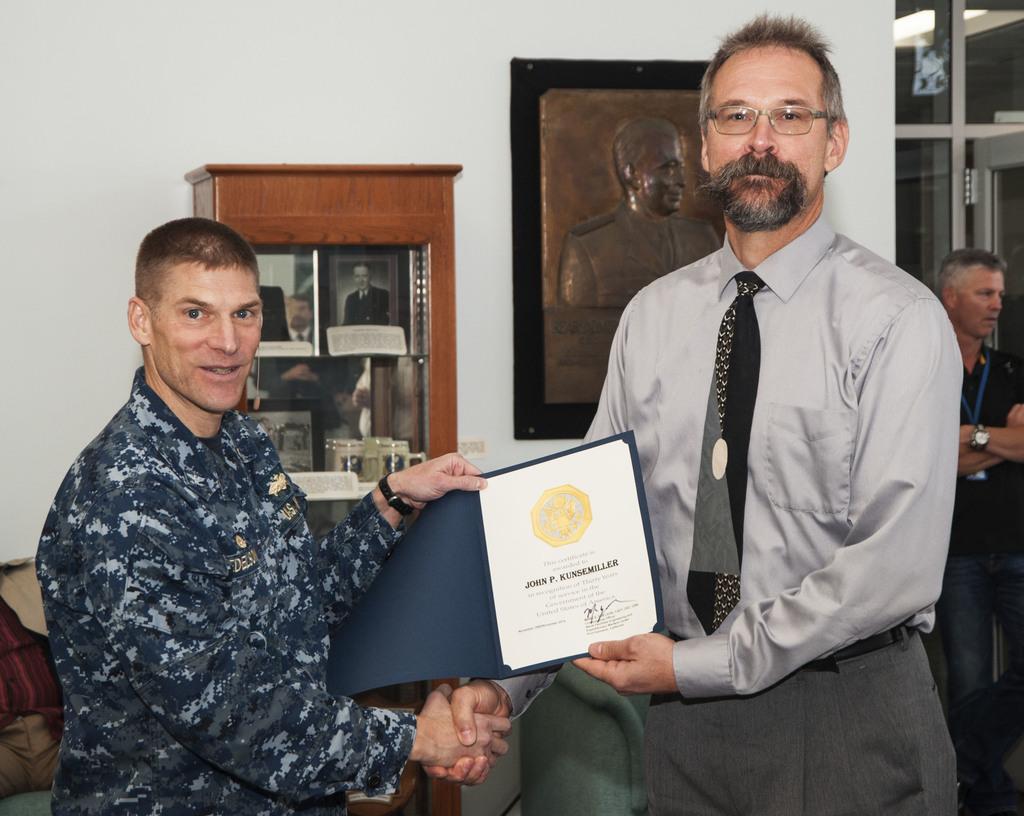Can you describe this image briefly? In this image, we can see two men standing and they are holding a certificate, at the right side there is a man standing, in the background there is a white color wall, on that wall there is a photo frame. 